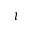Convert formula to latex. <formula><loc_0><loc_0><loc_500><loc_500>\iota</formula> 